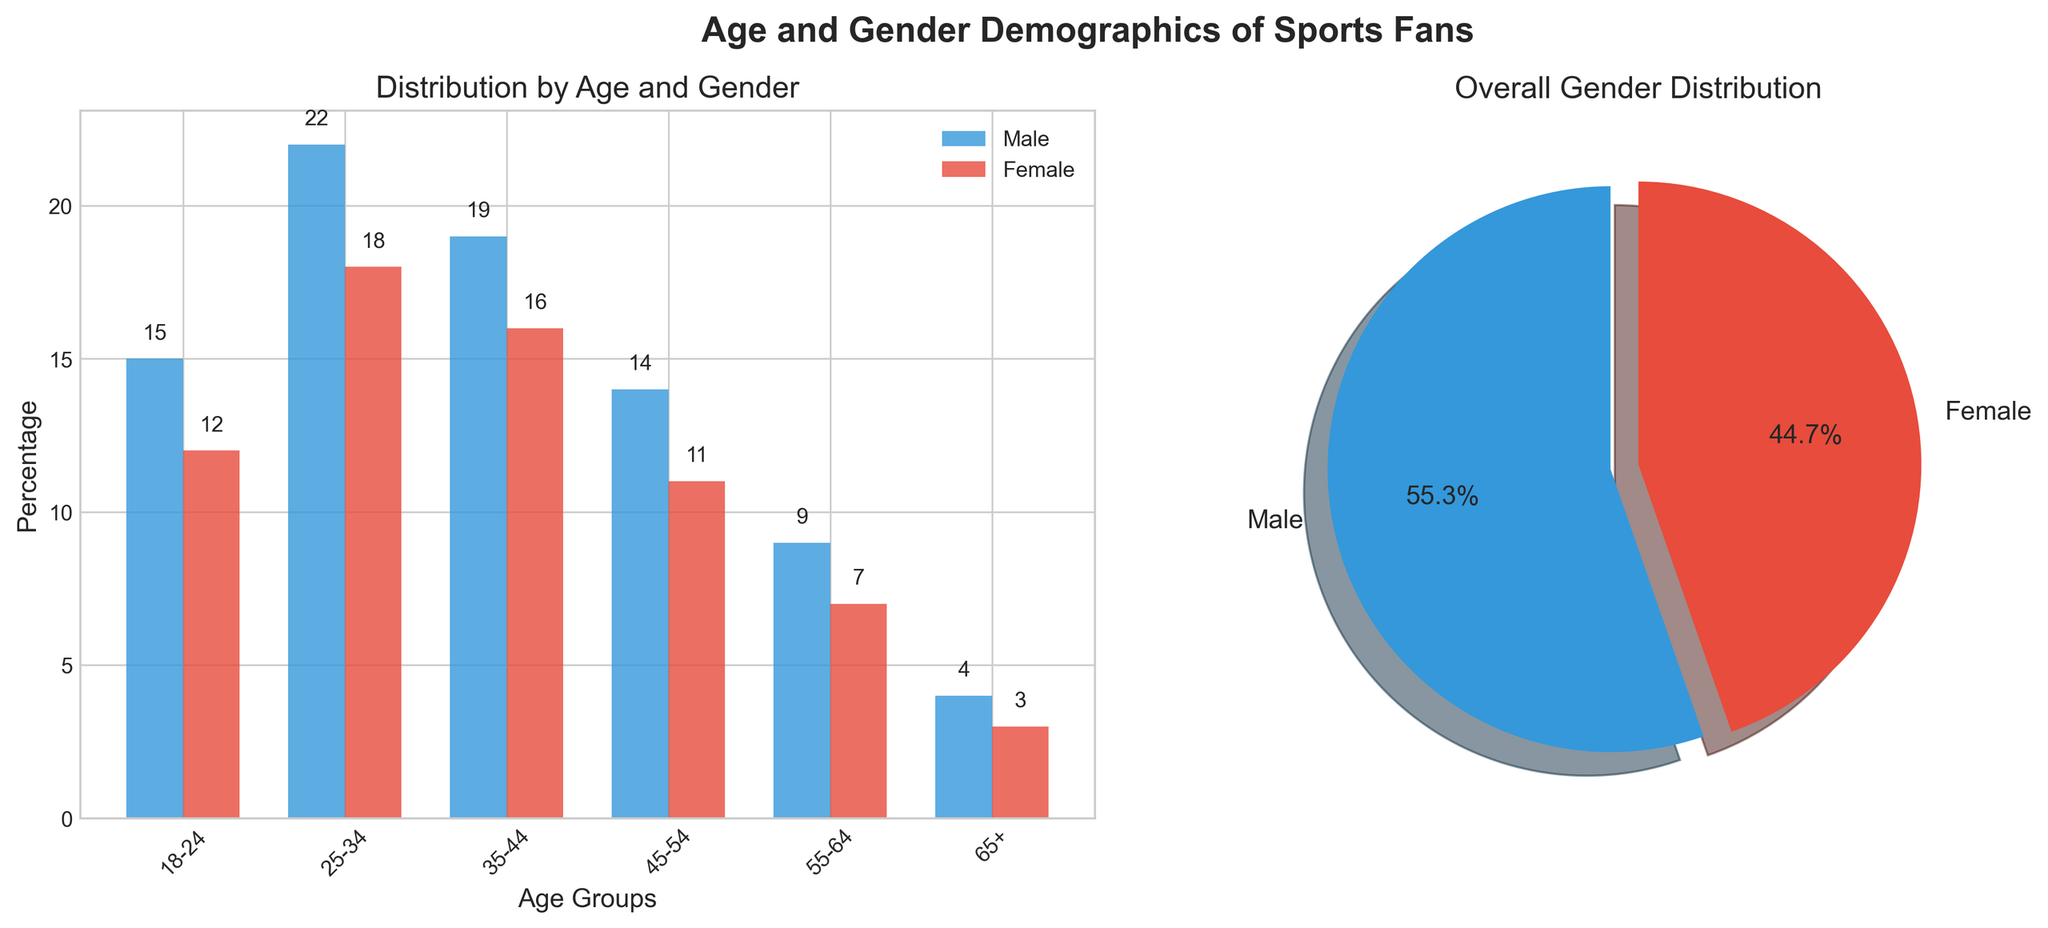Which age group has the highest percentage of male sports fans? The subplot of the bar chart shows that the age group with the highest bar for male sports fans is 25-34 years old with a percentage of 22%
Answer: 25-34 How much higher is the percentage of female fans in the 35-44 age group compared to the 65+ age group? The bar chart shows that the percentage of female fans in the 35-44 age group is 16% and in the 65+ age group is 3%. The difference is 16 - 3 = 13%
Answer: 13% What is the total percentage of female fans across all age groups? Summing the percentages of female fans in each age group from the bar chart: 12 + 18 + 16 + 11 + 7 + 3 = 67%
Answer: 67% Which gender has a higher total percentage of sports fans? From the pie chart, the sizes are provided for the overall gender distribution. The larger slice, which is for males, indicates that males have a higher total percentage than females
Answer: Male What is the percentage difference between male and female fans in the 45-54 age group? According to the bar chart, the percentage for males in the 45-54 age group is 14% and for females is 11%. The difference is 14 - 11 = 3%
Answer: 3% Which age group has the closest percentage of male and female fans? By examining the bar lengths in the bar chart, the 45-54 age group has male fans at 14% and female fans at 11%, with a difference of only 3%, which is the closest among all groups
Answer: 45-54 What is the combined percentage of fans in the 18-24 and 55-64 age groups? Adding the percentages of the 18-24 age group (15% + 12%) and the 55-64 age group (9% + 7%), we get 27% + 16% = 43%
Answer: 43% What is the percentage disparity between male and female fans in the overall gender distribution? According to the pie chart, the overall distribution is indicated with percentages. The pie slices display 57% male and 43% female fans. The disparity is 57 - 43 = 14%
Answer: 14% In which age group do females make up the largest percentage of sports fans? The bar chart shows that the age group with the tallest bar for female fans is 25-34 years old with a percentage of 18%
Answer: 25-34 